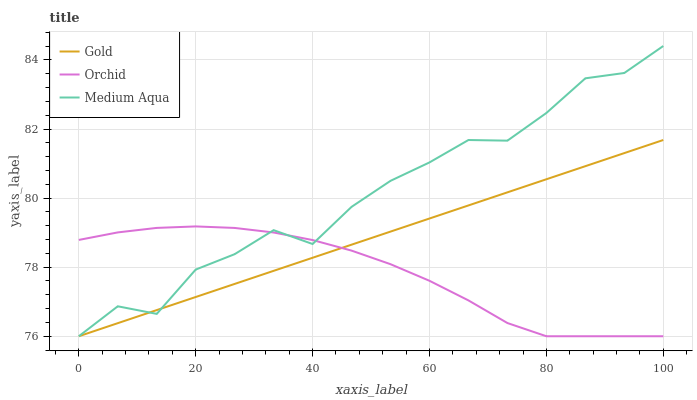Does Orchid have the minimum area under the curve?
Answer yes or no. Yes. Does Medium Aqua have the maximum area under the curve?
Answer yes or no. Yes. Does Gold have the minimum area under the curve?
Answer yes or no. No. Does Gold have the maximum area under the curve?
Answer yes or no. No. Is Gold the smoothest?
Answer yes or no. Yes. Is Medium Aqua the roughest?
Answer yes or no. Yes. Is Orchid the smoothest?
Answer yes or no. No. Is Orchid the roughest?
Answer yes or no. No. Does Medium Aqua have the lowest value?
Answer yes or no. Yes. Does Medium Aqua have the highest value?
Answer yes or no. Yes. Does Gold have the highest value?
Answer yes or no. No. Does Medium Aqua intersect Orchid?
Answer yes or no. Yes. Is Medium Aqua less than Orchid?
Answer yes or no. No. Is Medium Aqua greater than Orchid?
Answer yes or no. No. 